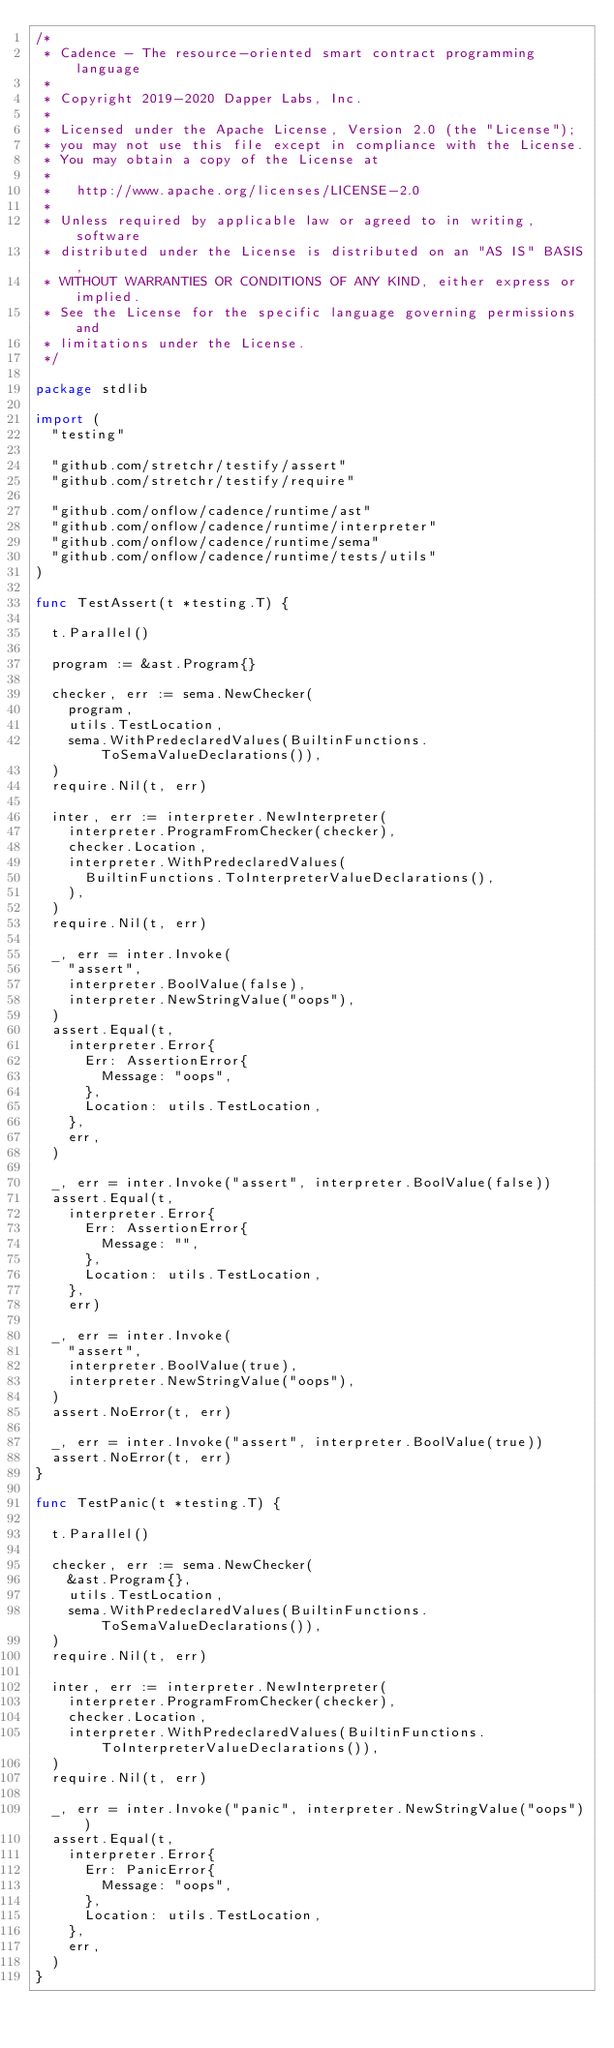Convert code to text. <code><loc_0><loc_0><loc_500><loc_500><_Go_>/*
 * Cadence - The resource-oriented smart contract programming language
 *
 * Copyright 2019-2020 Dapper Labs, Inc.
 *
 * Licensed under the Apache License, Version 2.0 (the "License");
 * you may not use this file except in compliance with the License.
 * You may obtain a copy of the License at
 *
 *   http://www.apache.org/licenses/LICENSE-2.0
 *
 * Unless required by applicable law or agreed to in writing, software
 * distributed under the License is distributed on an "AS IS" BASIS,
 * WITHOUT WARRANTIES OR CONDITIONS OF ANY KIND, either express or implied.
 * See the License for the specific language governing permissions and
 * limitations under the License.
 */

package stdlib

import (
	"testing"

	"github.com/stretchr/testify/assert"
	"github.com/stretchr/testify/require"

	"github.com/onflow/cadence/runtime/ast"
	"github.com/onflow/cadence/runtime/interpreter"
	"github.com/onflow/cadence/runtime/sema"
	"github.com/onflow/cadence/runtime/tests/utils"
)

func TestAssert(t *testing.T) {

	t.Parallel()

	program := &ast.Program{}

	checker, err := sema.NewChecker(
		program,
		utils.TestLocation,
		sema.WithPredeclaredValues(BuiltinFunctions.ToSemaValueDeclarations()),
	)
	require.Nil(t, err)

	inter, err := interpreter.NewInterpreter(
		interpreter.ProgramFromChecker(checker),
		checker.Location,
		interpreter.WithPredeclaredValues(
			BuiltinFunctions.ToInterpreterValueDeclarations(),
		),
	)
	require.Nil(t, err)

	_, err = inter.Invoke(
		"assert",
		interpreter.BoolValue(false),
		interpreter.NewStringValue("oops"),
	)
	assert.Equal(t,
		interpreter.Error{
			Err: AssertionError{
				Message: "oops",
			},
			Location: utils.TestLocation,
		},
		err,
	)

	_, err = inter.Invoke("assert", interpreter.BoolValue(false))
	assert.Equal(t,
		interpreter.Error{
			Err: AssertionError{
				Message: "",
			},
			Location: utils.TestLocation,
		},
		err)

	_, err = inter.Invoke(
		"assert",
		interpreter.BoolValue(true),
		interpreter.NewStringValue("oops"),
	)
	assert.NoError(t, err)

	_, err = inter.Invoke("assert", interpreter.BoolValue(true))
	assert.NoError(t, err)
}

func TestPanic(t *testing.T) {

	t.Parallel()

	checker, err := sema.NewChecker(
		&ast.Program{},
		utils.TestLocation,
		sema.WithPredeclaredValues(BuiltinFunctions.ToSemaValueDeclarations()),
	)
	require.Nil(t, err)

	inter, err := interpreter.NewInterpreter(
		interpreter.ProgramFromChecker(checker),
		checker.Location,
		interpreter.WithPredeclaredValues(BuiltinFunctions.ToInterpreterValueDeclarations()),
	)
	require.Nil(t, err)

	_, err = inter.Invoke("panic", interpreter.NewStringValue("oops"))
	assert.Equal(t,
		interpreter.Error{
			Err: PanicError{
				Message: "oops",
			},
			Location: utils.TestLocation,
		},
		err,
	)
}
</code> 